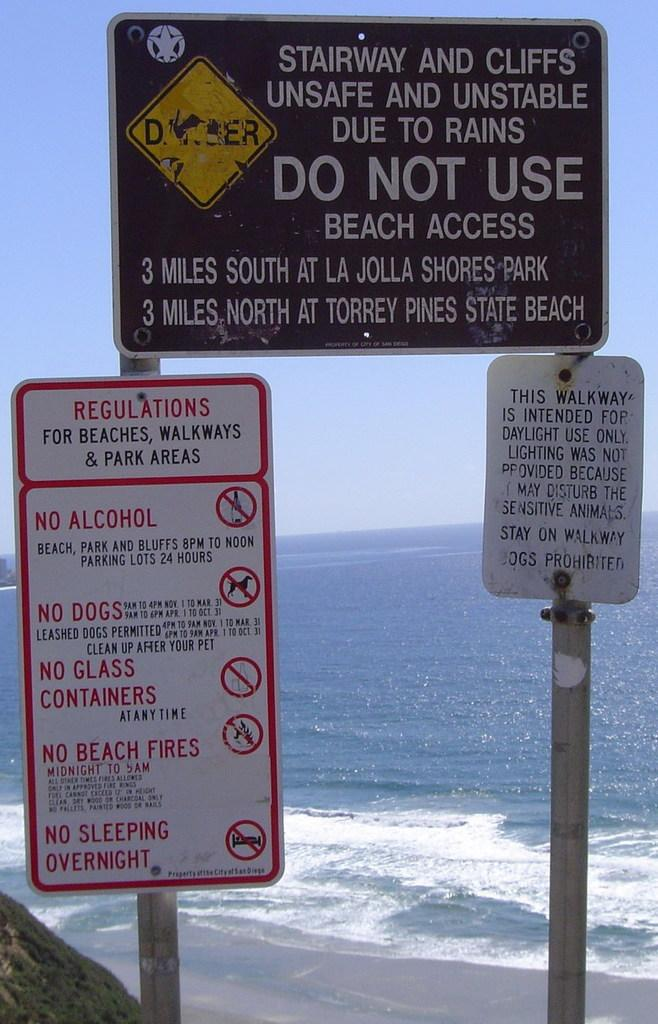Provide a one-sentence caption for the provided image. Three differenty sized signs are on poles warning people to not use the stairway and cliffs. 